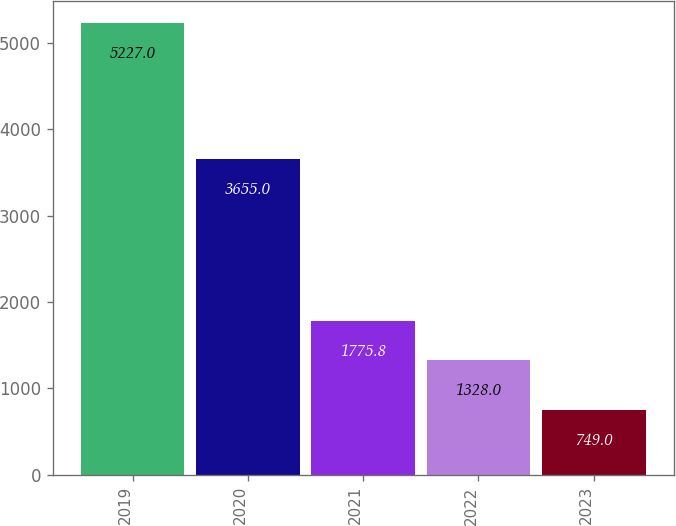<chart> <loc_0><loc_0><loc_500><loc_500><bar_chart><fcel>2019<fcel>2020<fcel>2021<fcel>2022<fcel>2023<nl><fcel>5227<fcel>3655<fcel>1775.8<fcel>1328<fcel>749<nl></chart> 